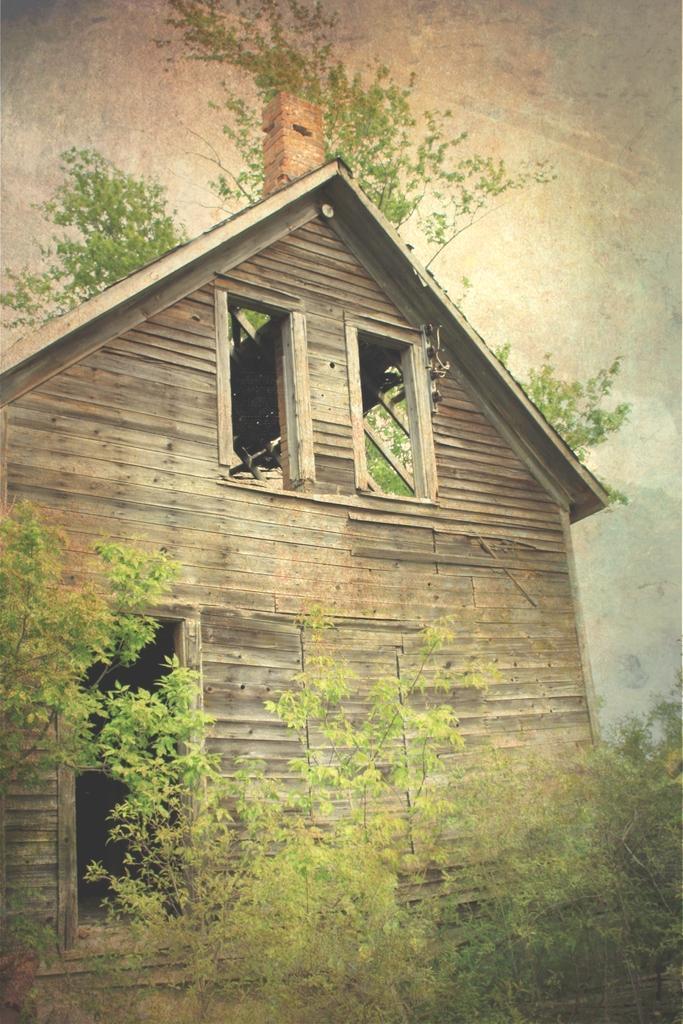Could you give a brief overview of what you see in this image? At the bottom of the picture, we see the trees. In the middle, we see a wooden hut. There are trees in the background. At the top, we see the sky. 